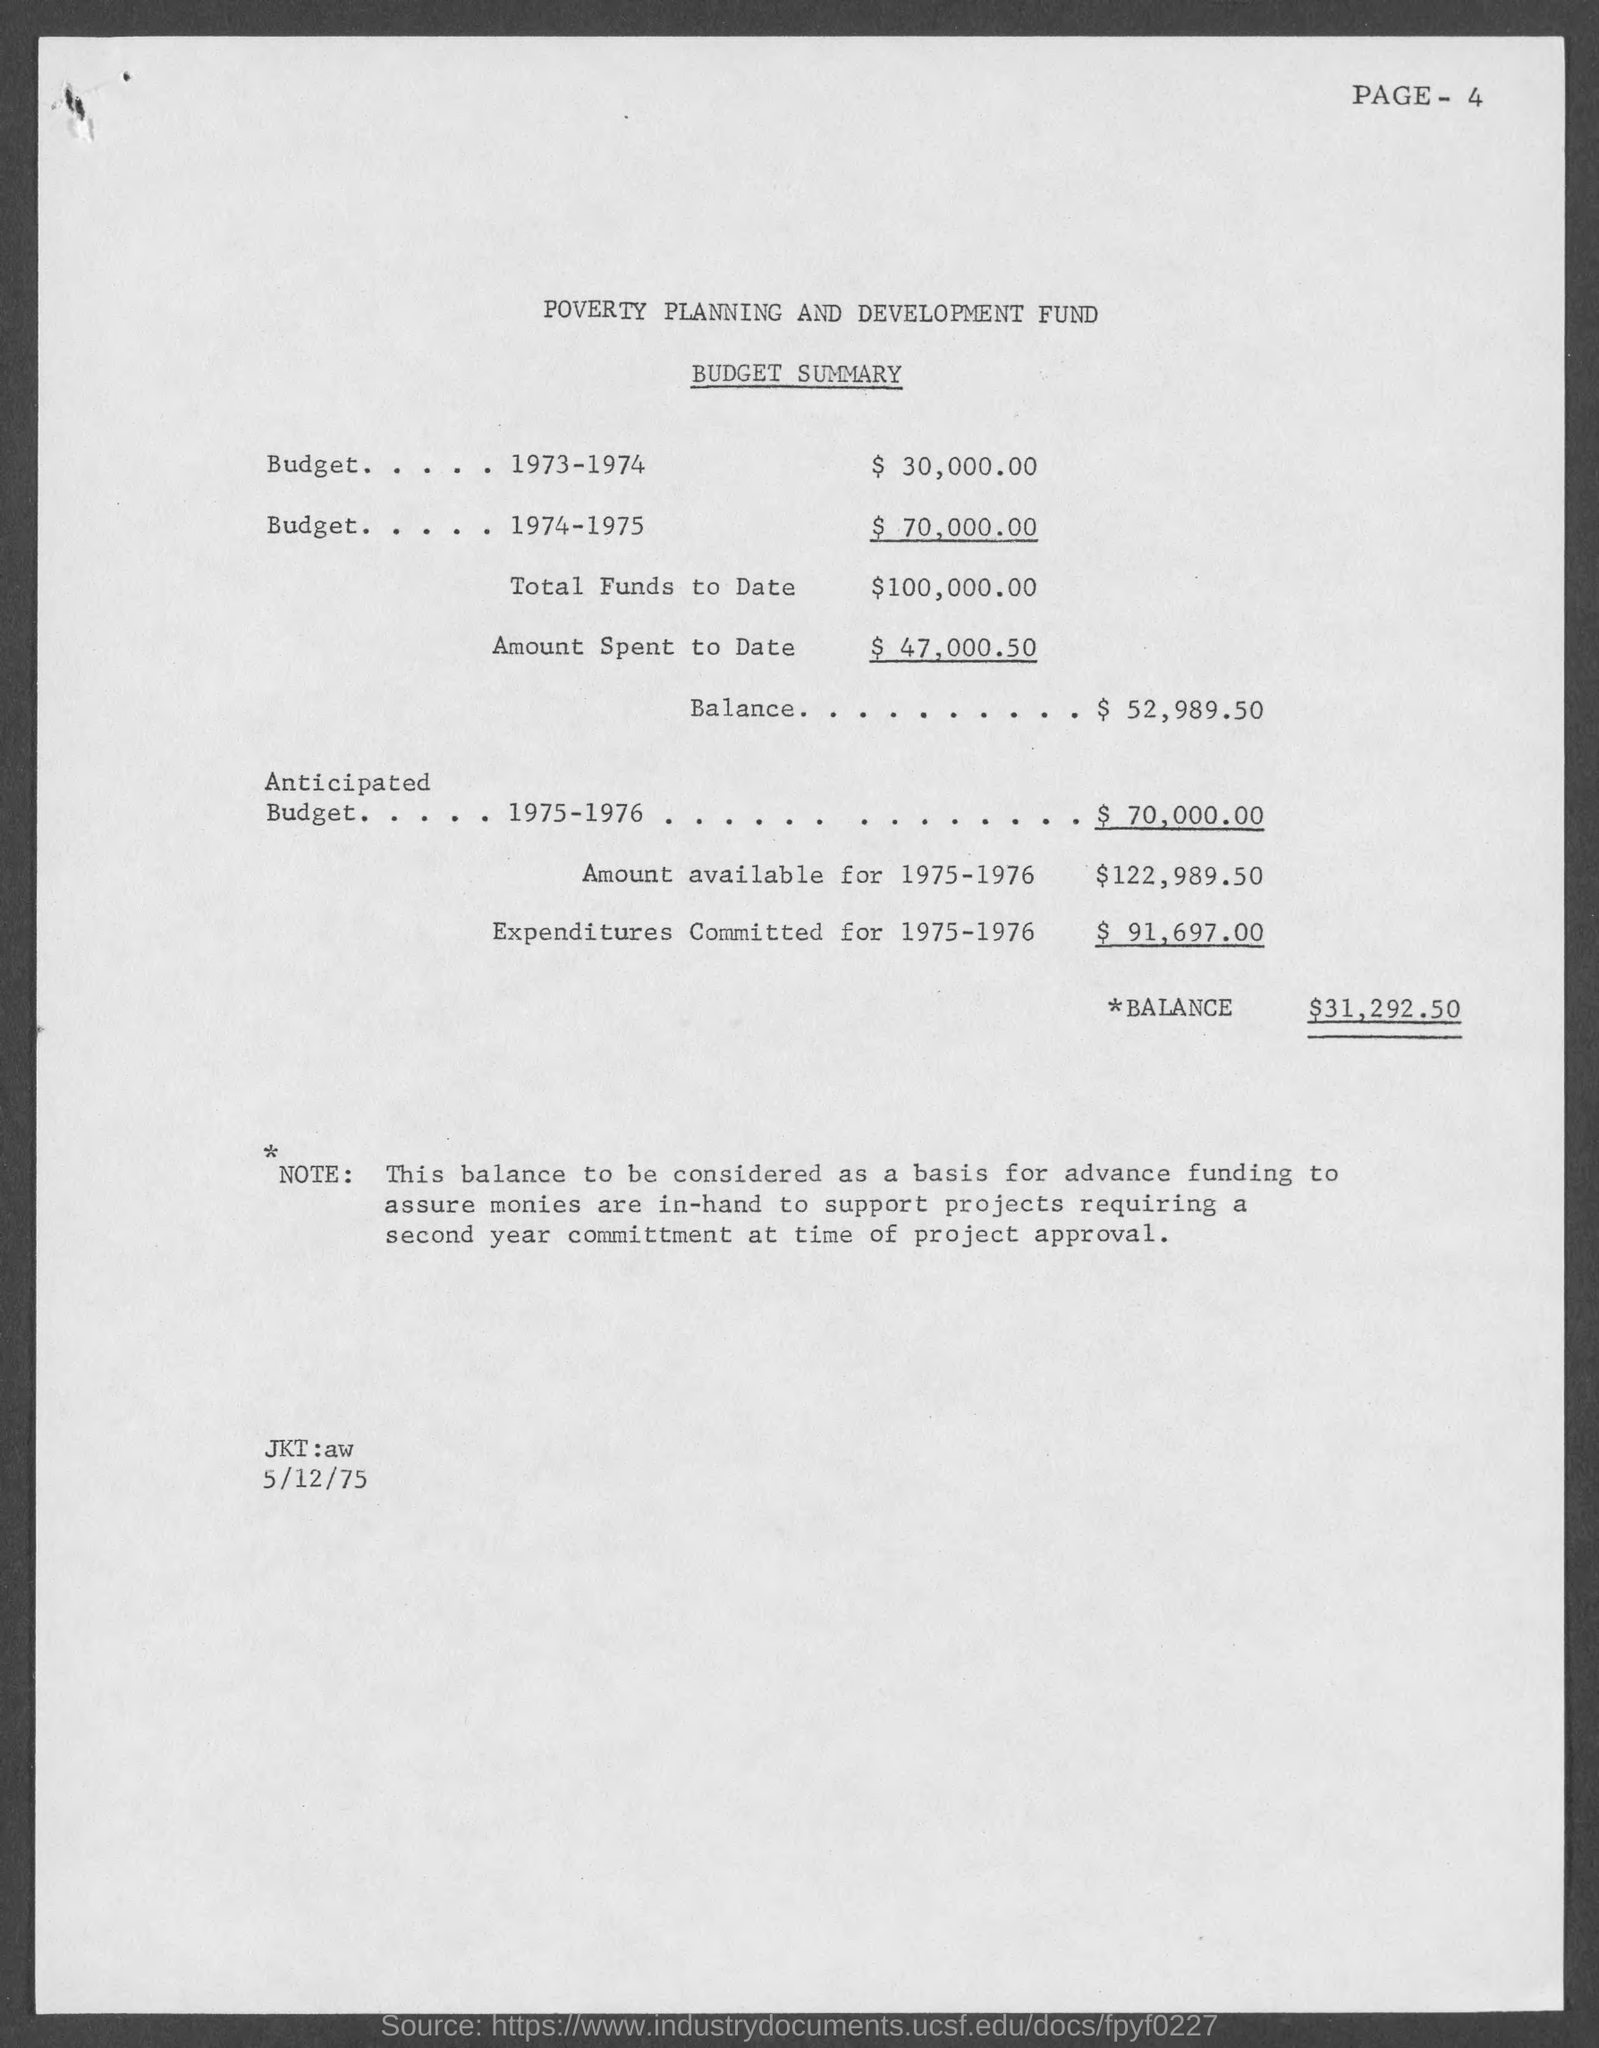Indicate a few pertinent items in this graphic. In the year 1974-1975, the budget estimate was $70,000.00. The budget summary for the expenditures committed for 1975-1976 is $91,697.00. The budget summary for 1975-1976 mentions an available amount of 122,989.50. The anticipated budget for the year 1975-1976 is $70,000.00. The budget estimate for the year 1973-1974 was $30,000.00. 